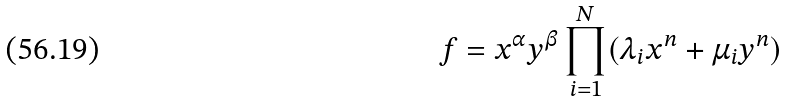<formula> <loc_0><loc_0><loc_500><loc_500>f = x ^ { \alpha } y ^ { \beta } \prod _ { i = 1 } ^ { N } ( \lambda _ { i } x ^ { n } + \mu _ { i } y ^ { n } )</formula> 